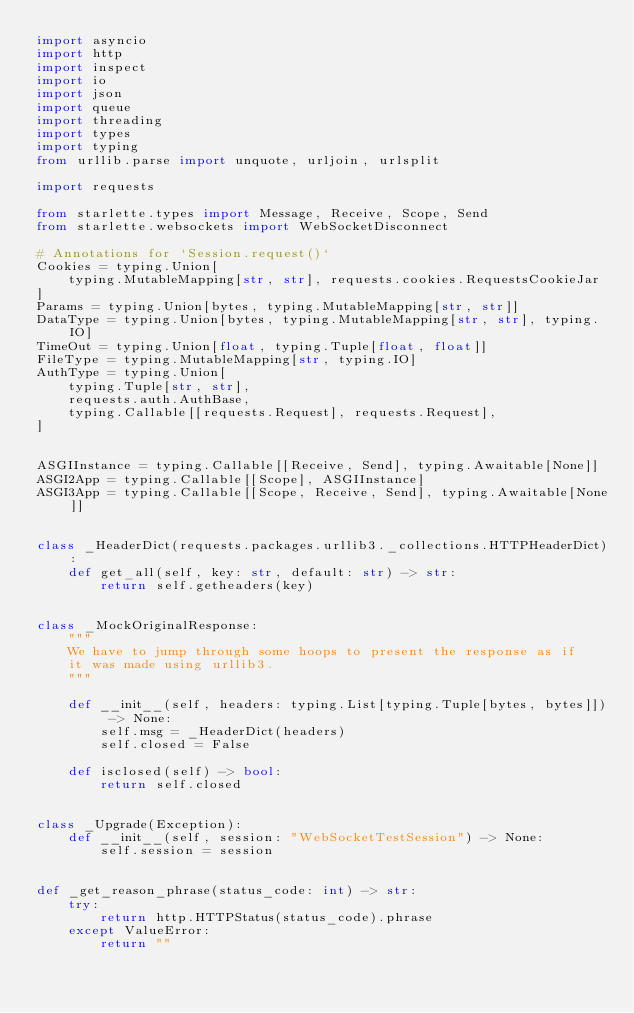Convert code to text. <code><loc_0><loc_0><loc_500><loc_500><_Python_>import asyncio
import http
import inspect
import io
import json
import queue
import threading
import types
import typing
from urllib.parse import unquote, urljoin, urlsplit

import requests

from starlette.types import Message, Receive, Scope, Send
from starlette.websockets import WebSocketDisconnect

# Annotations for `Session.request()`
Cookies = typing.Union[
    typing.MutableMapping[str, str], requests.cookies.RequestsCookieJar
]
Params = typing.Union[bytes, typing.MutableMapping[str, str]]
DataType = typing.Union[bytes, typing.MutableMapping[str, str], typing.IO]
TimeOut = typing.Union[float, typing.Tuple[float, float]]
FileType = typing.MutableMapping[str, typing.IO]
AuthType = typing.Union[
    typing.Tuple[str, str],
    requests.auth.AuthBase,
    typing.Callable[[requests.Request], requests.Request],
]


ASGIInstance = typing.Callable[[Receive, Send], typing.Awaitable[None]]
ASGI2App = typing.Callable[[Scope], ASGIInstance]
ASGI3App = typing.Callable[[Scope, Receive, Send], typing.Awaitable[None]]


class _HeaderDict(requests.packages.urllib3._collections.HTTPHeaderDict):
    def get_all(self, key: str, default: str) -> str:
        return self.getheaders(key)


class _MockOriginalResponse:
    """
    We have to jump through some hoops to present the response as if
    it was made using urllib3.
    """

    def __init__(self, headers: typing.List[typing.Tuple[bytes, bytes]]) -> None:
        self.msg = _HeaderDict(headers)
        self.closed = False

    def isclosed(self) -> bool:
        return self.closed


class _Upgrade(Exception):
    def __init__(self, session: "WebSocketTestSession") -> None:
        self.session = session


def _get_reason_phrase(status_code: int) -> str:
    try:
        return http.HTTPStatus(status_code).phrase
    except ValueError:
        return ""

</code> 